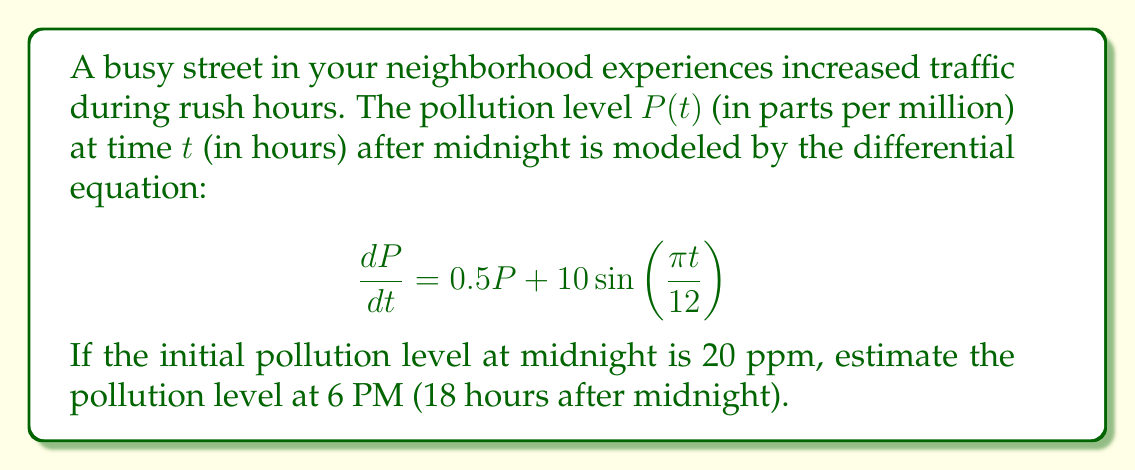Teach me how to tackle this problem. To solve this first-order linear differential equation, we can use the integrating factor method:

1) The integrating factor is $\mu(t) = e^{\int 0.5 dt} = e^{0.5t}$

2) Multiply both sides of the equation by $\mu(t)$:

   $$e^{0.5t}\frac{dP}{dt} = 0.5Pe^{0.5t} + 10e^{0.5t}\sin(\frac{\pi t}{12})$$

3) The left side is now the derivative of $Pe^{0.5t}$:

   $$\frac{d}{dt}(Pe^{0.5t}) = 10e^{0.5t}\sin(\frac{\pi t}{12})$$

4) Integrate both sides:

   $$Pe^{0.5t} = \int 10e^{0.5t}\sin(\frac{\pi t}{12}) dt + C$$

5) Using integration by parts, we get:

   $$Pe^{0.5t} = 10[\frac{6e^{0.5t}}{\pi^2+9}\sin(\frac{\pi t}{12}) - \frac{2\pi e^{0.5t}}{\pi^2+9}\cos(\frac{\pi t}{12})] + C$$

6) Solve for $P$:

   $$P = 10[\frac{6}{\pi^2+9}\sin(\frac{\pi t}{12}) - \frac{2\pi}{\pi^2+9}\cos(\frac{\pi t}{12})] + Ce^{-0.5t}$$

7) Use the initial condition $P(0) = 20$ to find $C$:

   $$20 = -\frac{20\pi}{\pi^2+9} + C$$
   $$C = 20 + \frac{20\pi}{\pi^2+9}$$

8) Substitute this back into the general solution:

   $$P(t) = 10[\frac{6}{\pi^2+9}\sin(\frac{\pi t}{12}) - \frac{2\pi}{\pi^2+9}\cos(\frac{\pi t}{12})] + (20 + \frac{20\pi}{\pi^2+9})e^{-0.5t}$$

9) Evaluate at $t = 18$ (6 PM):

   $$P(18) \approx 10[\frac{6}{\pi^2+9}\sin(\frac{3\pi}{2}) - \frac{2\pi}{\pi^2+9}\cos(\frac{3\pi}{2})] + (20 + \frac{20\pi}{\pi^2+9})e^{-9}$$

10) Calculate the final result:

    $$P(18) \approx 60.7 \text{ ppm}$$
Answer: The estimated pollution level at 6 PM is approximately 60.7 ppm. 